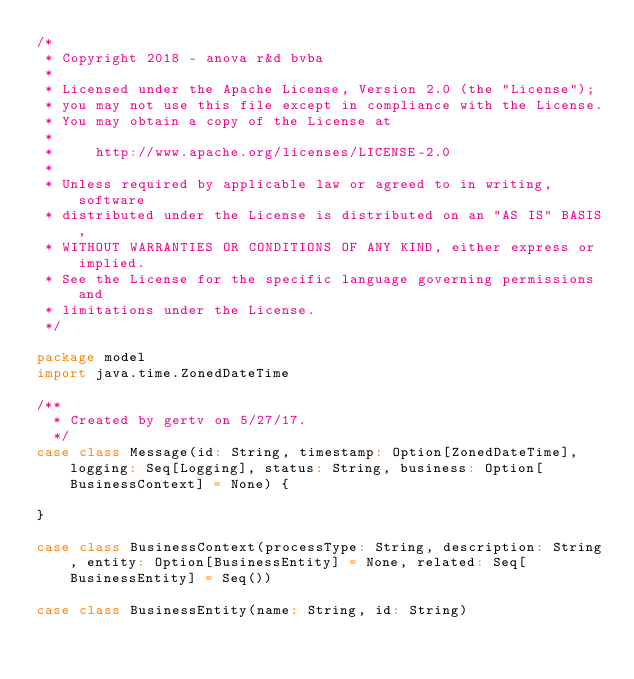<code> <loc_0><loc_0><loc_500><loc_500><_Scala_>/*
 * Copyright 2018 - anova r&d bvba
 *
 * Licensed under the Apache License, Version 2.0 (the "License");
 * you may not use this file except in compliance with the License.
 * You may obtain a copy of the License at
 *
 *     http://www.apache.org/licenses/LICENSE-2.0
 *
 * Unless required by applicable law or agreed to in writing, software
 * distributed under the License is distributed on an "AS IS" BASIS,
 * WITHOUT WARRANTIES OR CONDITIONS OF ANY KIND, either express or implied.
 * See the License for the specific language governing permissions and
 * limitations under the License.
 */

package model
import java.time.ZonedDateTime

/**
  * Created by gertv on 5/27/17.
  */
case class Message(id: String, timestamp: Option[ZonedDateTime], logging: Seq[Logging], status: String, business: Option[BusinessContext] = None) {

}

case class BusinessContext(processType: String, description: String, entity: Option[BusinessEntity] = None, related: Seq[BusinessEntity] = Seq())

case class BusinessEntity(name: String, id: String)


</code> 